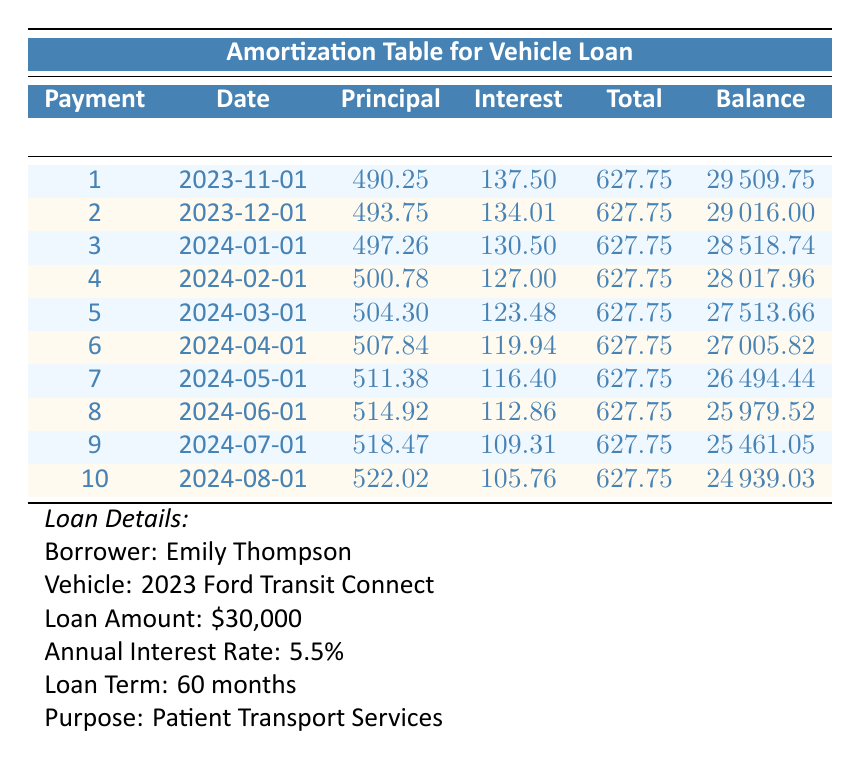What is the total payment amount for the first month? The total payment amount is listed in the first row of the table, under the "Total" column for payment number 1, which shows $627.75.
Answer: 627.75 What is the interest payment for the second month? In the second row under the "Interest" column for payment number 2, the amount is $134.01.
Answer: 134.01 Is the remaining balance after the fifth payment lower than $27,000? The remaining balance after the fifth payment (shown in the table) is $27,513.66, which is higher than $27,000.
Answer: No What is the average principal payment over the first ten months? To find the average principal payment, we sum the principal payments from the first ten months: 490.25 + 493.75 + 497.26 + 500.78 + 504.30 + 507.84 + 511.38 + 514.92 + 518.47 + 522.02 = 5,337.27. Dividing this sum by 10 gives the average: 5,337.27 / 10 = 533.73.
Answer: 533.73 What is the total interest paid after the first four payments? The total interest paid can be calculated by summing the interest payments from the first four months: 137.50 + 134.01 + 130.50 + 127.00 = 529.01.
Answer: 529.01 What is the remaining balance after the seventh payment? The remaining balance after the seventh payment, displayed in the seventh row under the "Balance" column, is $26,494.44.
Answer: 26494.44 Does the principal payment increase or decrease over the first ten payments? By examining the principal payments in the table, we can see that the principal payments increase from $490.25 in the first payment to $522.02 in the tenth payment. Therefore, the principal payments increase.
Answer: Yes What was the total payment made by the borrower after the first three payments? To find the total payments after the first three months, we sum the total payments: 627.75 + 627.75 + 627.75 = 1,883.25.
Answer: 1883.25 What is the difference in total amount paid in principal between the first and third payments? The difference in principal payments can be calculated by subtracting the first month's principal payment from the third month's: 497.26 - 490.25 = 7.01.
Answer: 7.01 